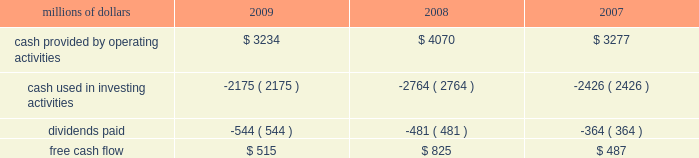2022 asset utilization 2013 in response to economic conditions and lower revenue in 2009 , we implemented productivity initiatives to improve efficiency and reduce costs , in addition to adjusting our resources to reflect lower demand .
Although varying throughout the year , our resource reductions included removing from service approximately 26% ( 26 % ) of our road locomotives and 18% ( 18 % ) of our freight car inventory by year end .
We also reduced shift levels at most rail facilities and closed or significantly reduced operations in 30 of our 114 principal rail yards .
These demand-driven resource adjustments and our productivity initiatives combined to reduce our workforce by 10% ( 10 % ) .
2022 fuel prices 2013 as the economy worsened during the third and fourth quarters of 2008 , fuel prices dropped dramatically , reaching $ 33.87 per barrel in december 2008 , a near five-year low .
Throughout 2009 , crude oil prices generally increased , ending the year around $ 80 per barrel .
Overall , our average fuel price decreased by 44% ( 44 % ) in 2009 , reducing operating expenses by $ 1.3 billion compared to 2008 .
We also reduced our consumption rate by 4% ( 4 % ) during the year , saving approximately 40 million gallons of fuel .
The use of newer , more fuel efficient locomotives ; increased use of distributed locomotive power ; fuel conservation programs ; and improved network operations and asset utilization all contributed to this improvement .
2022 free cash flow 2013 cash generated by operating activities totaled $ 3.2 billion , yielding free cash flow of $ 515 million in 2009 .
Free cash flow is defined as cash provided by operating activities , less cash used in investing activities and dividends paid .
Free cash flow is not considered a financial measure under accounting principles generally accepted in the united states ( gaap ) by sec regulation g and item 10 of sec regulation s-k .
We believe free cash flow is important in evaluating our financial performance and measures our ability to generate cash without additional external financings .
Free cash flow should be considered in addition to , rather than as a substitute for , cash provided by operating activities .
The table reconciles cash provided by operating activities ( gaap measure ) to free cash flow ( non-gaap measure ) : millions of dollars 2009 2008 2007 .
2010 outlook 2022 safety 2013 operating a safe railroad benefits our employees , our customers , our shareholders , and the public .
We will continue using a multi-faceted approach to safety , utilizing technology , risk assessment , quality control , and training , and by engaging our employees .
We will continue implementing total safety culture ( tsc ) throughout our operations .
Tsc is designed to establish , maintain , reinforce , and promote safe practices among co-workers .
This process allows us to identify and implement best practices for employee and operational safety .
Reducing grade-crossing incidents is a critical aspect of our safety programs , and we will continue our efforts to maintain , upgrade , and close crossings ; install video cameras on locomotives ; and educate the public about crossing safety through our own programs , various industry programs , and other activities .
2022 transportation plan 2013 to build upon our success in recent years , we will continue evaluating traffic flows and network logistic patterns , which can be quite dynamic from year-to-year , to identify additional opportunities to simplify operations , remove network variability and improve network efficiency and asset utilization .
We plan to adjust manpower and our locomotive and rail car fleets to .
What was the percentage change in free cash flow from 2007 to 2008? 
Computations: ((825 - 487) / 487)
Answer: 0.69405. 